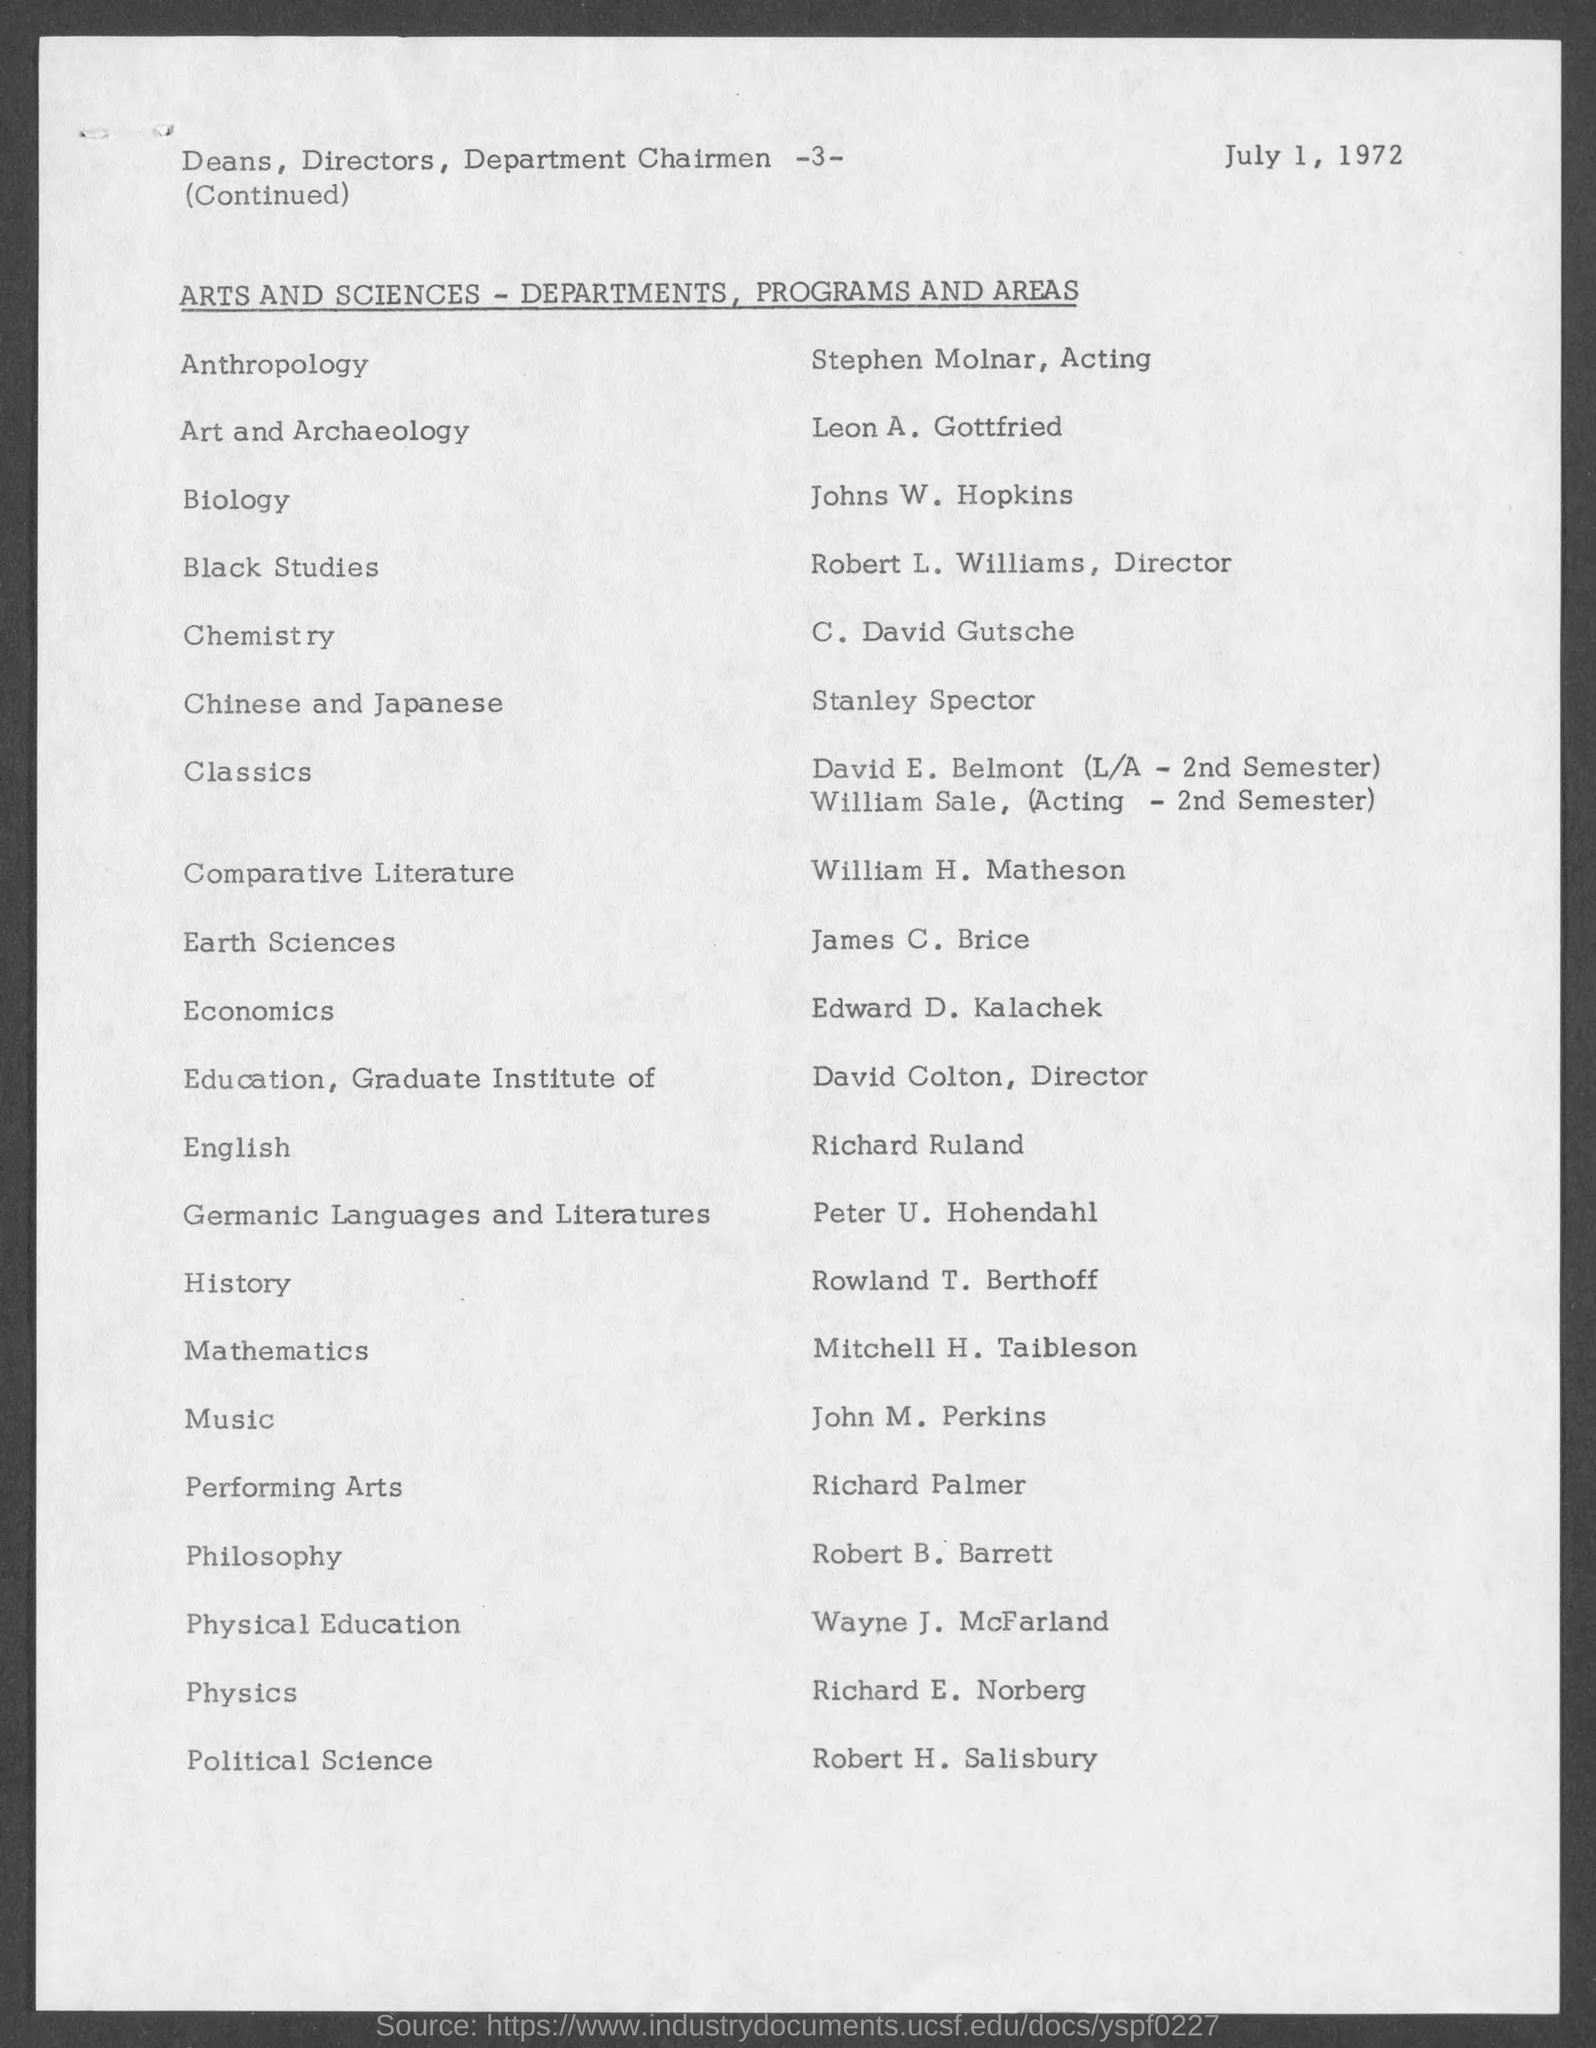What is the page number at top of the page?
Keep it short and to the point. 3. What is date and year mentioned in the document ?
Provide a succinct answer. July 1, 1972. To which department does Stephen Molnar belong to ?
Your response must be concise. Anthropology. To which department does Leon A. Gottfried belong to?
Make the answer very short. Art and Archaeology. To which department does Johns W. Hopkins belong to ?
Offer a very short reply. Biology. To which department does robert l. williams belong to ?
Make the answer very short. Black Studies. To which department does c. david gutsche belong to?
Your answer should be very brief. Chemistry. To which department does stanley spector belong to?
Your response must be concise. Chinese and japanese. To which department does Robert .H. Salisbury belong to?
Provide a short and direct response. Political science. To which department does Richard E. Norberg belong to?
Your answer should be compact. Physics. 